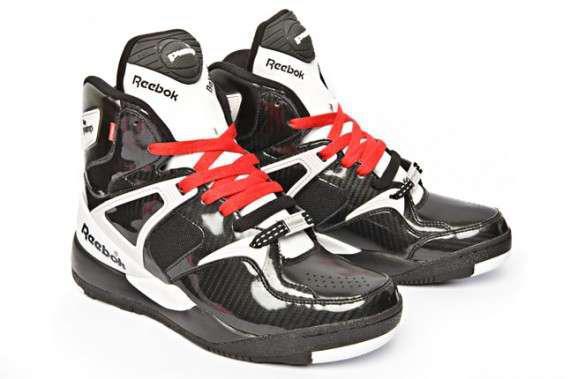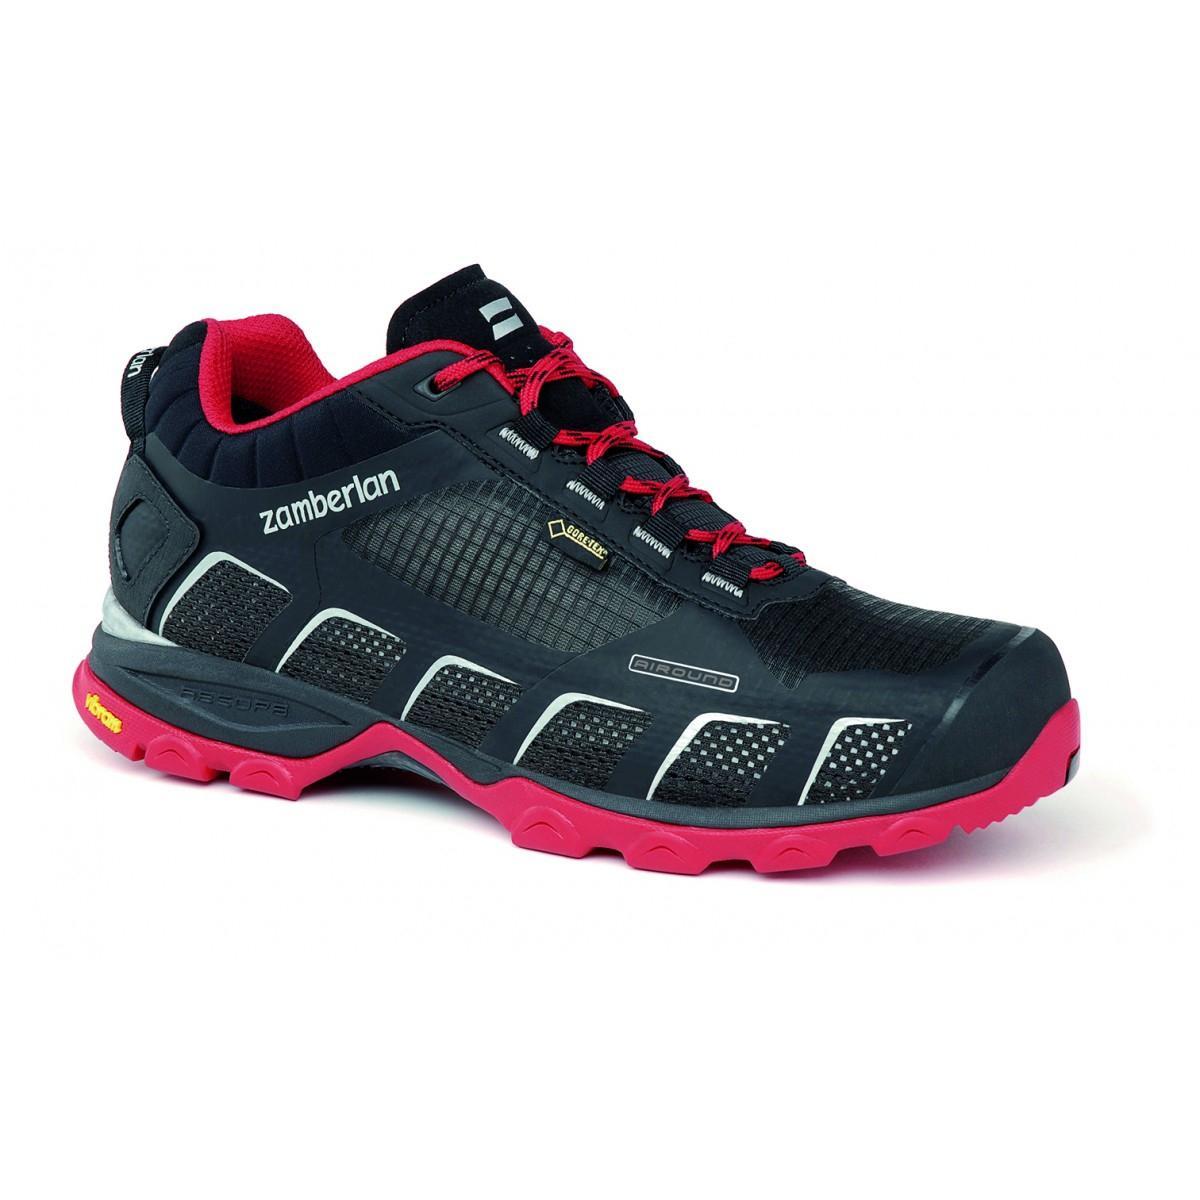The first image is the image on the left, the second image is the image on the right. Assess this claim about the two images: "There is at least one blue sneaker". Correct or not? Answer yes or no. No. The first image is the image on the left, the second image is the image on the right. For the images shown, is this caption "A total of four sneakers are shown in the images." true? Answer yes or no. No. 